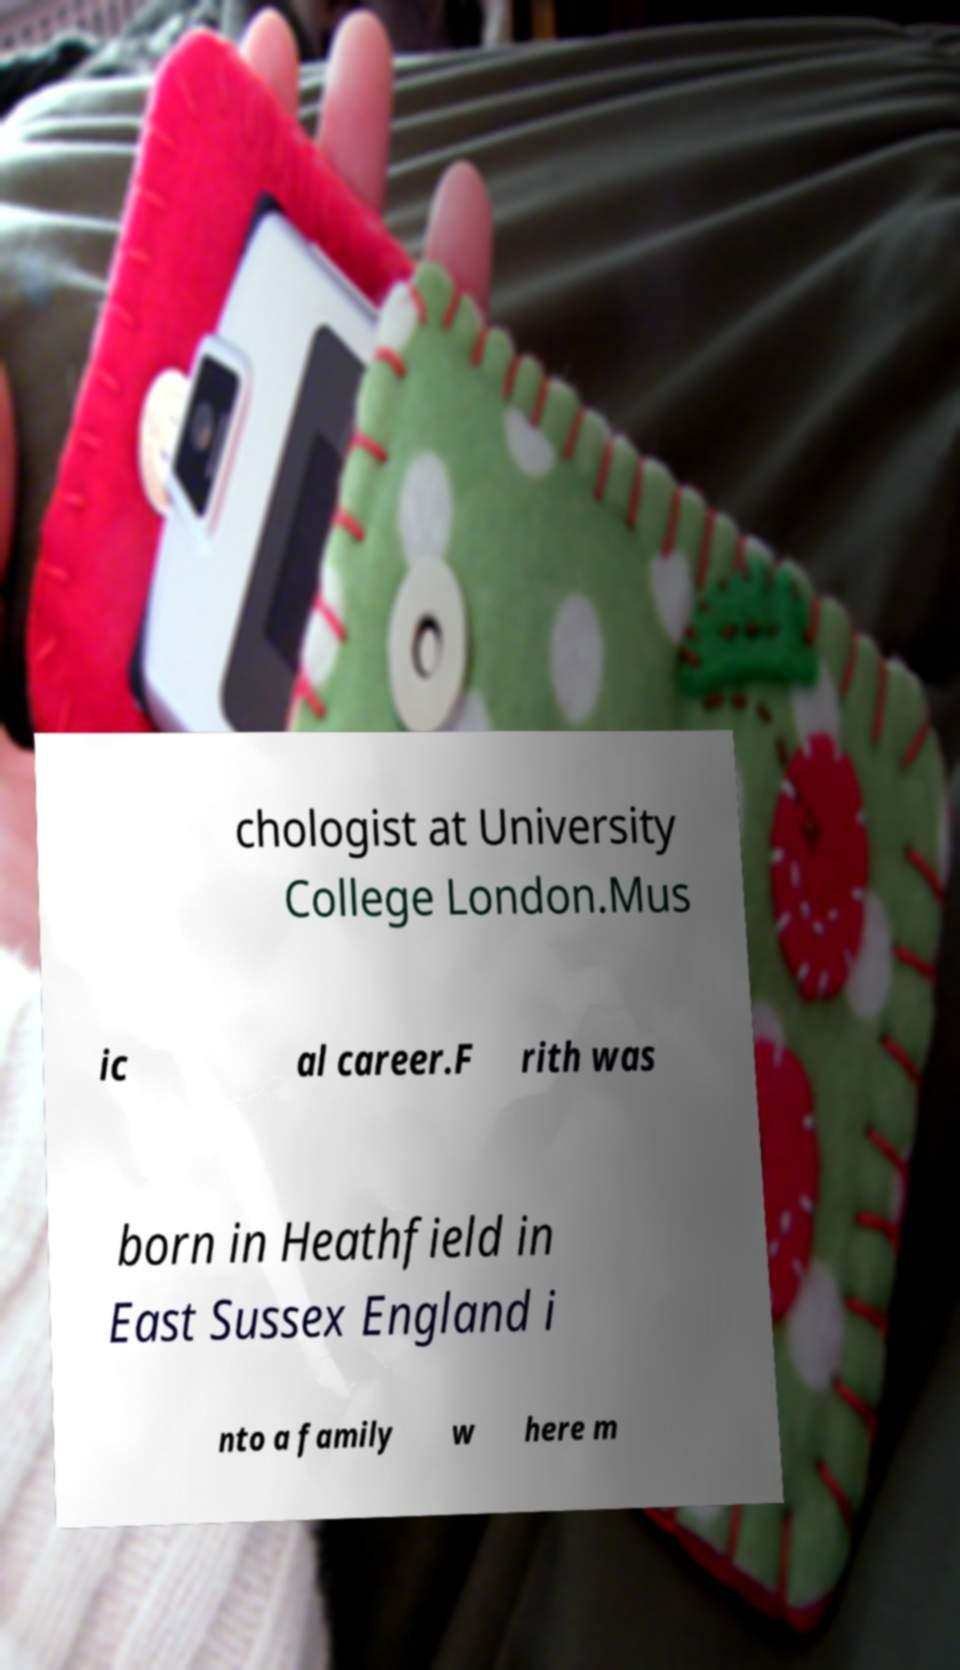Could you assist in decoding the text presented in this image and type it out clearly? chologist at University College London.Mus ic al career.F rith was born in Heathfield in East Sussex England i nto a family w here m 